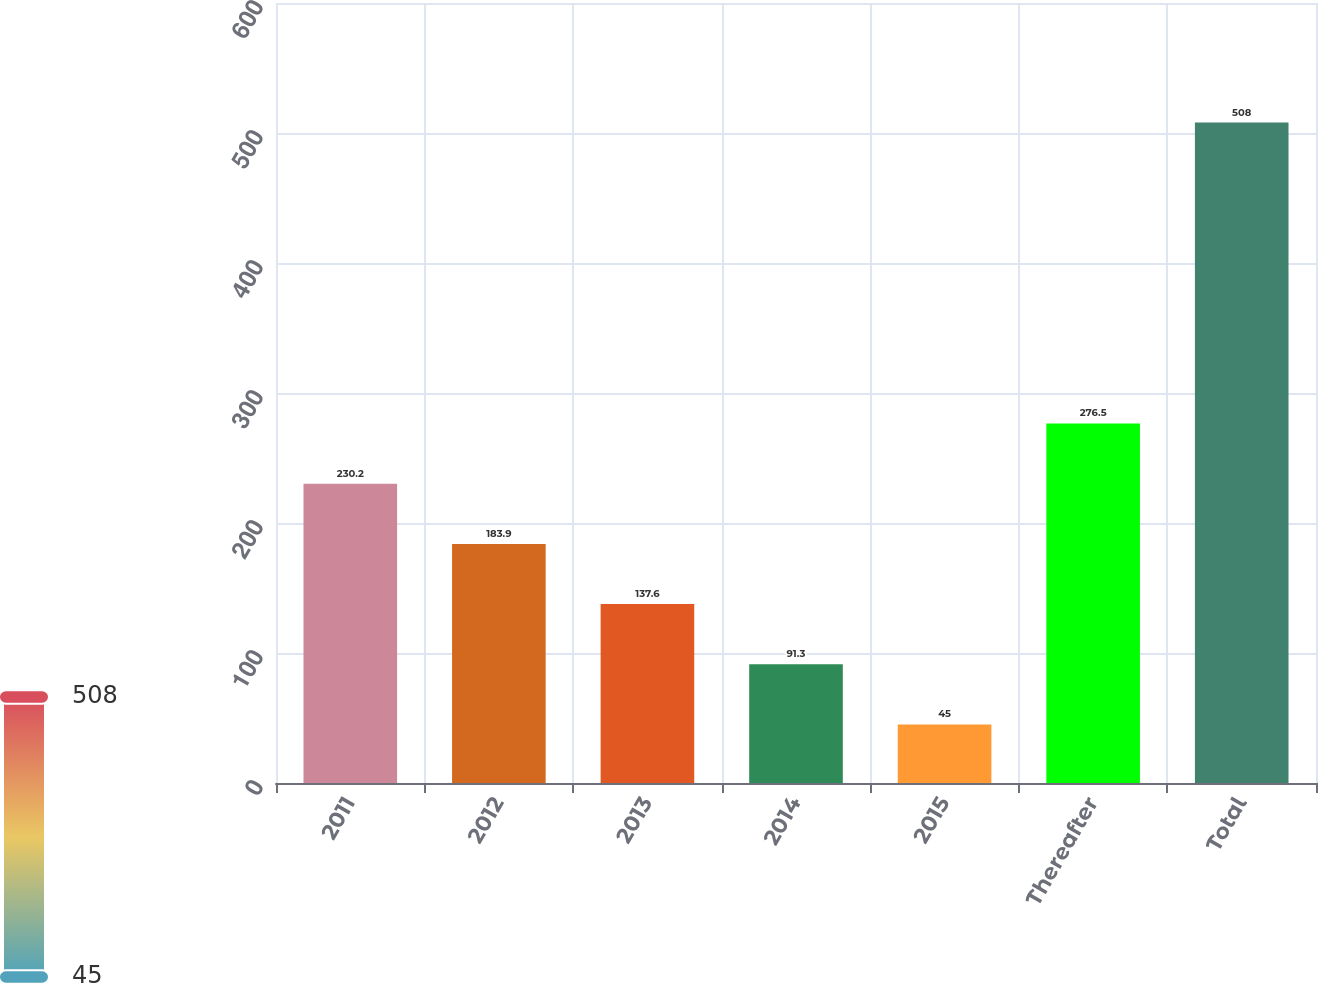<chart> <loc_0><loc_0><loc_500><loc_500><bar_chart><fcel>2011<fcel>2012<fcel>2013<fcel>2014<fcel>2015<fcel>Thereafter<fcel>Total<nl><fcel>230.2<fcel>183.9<fcel>137.6<fcel>91.3<fcel>45<fcel>276.5<fcel>508<nl></chart> 